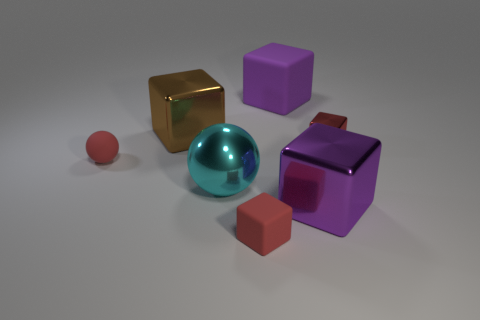Subtract all red metal cubes. How many cubes are left? 4 Subtract 2 blocks. How many blocks are left? 3 Add 2 big metal balls. How many objects exist? 9 Subtract all brown cubes. How many cubes are left? 4 Subtract all brown cubes. Subtract all gray balls. How many cubes are left? 4 Subtract all blocks. How many objects are left? 2 Add 4 large brown objects. How many large brown objects exist? 5 Subtract 0 gray cubes. How many objects are left? 7 Subtract all large red matte balls. Subtract all spheres. How many objects are left? 5 Add 5 purple blocks. How many purple blocks are left? 7 